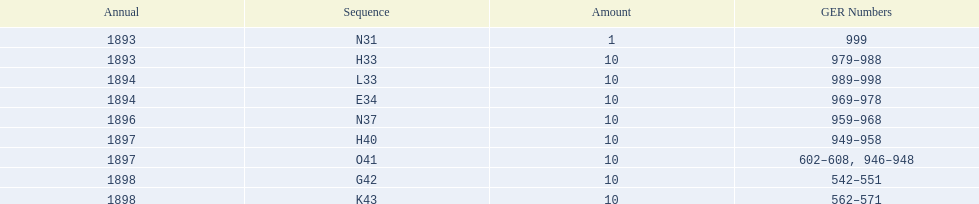Which order was the next order after l33? E34. 